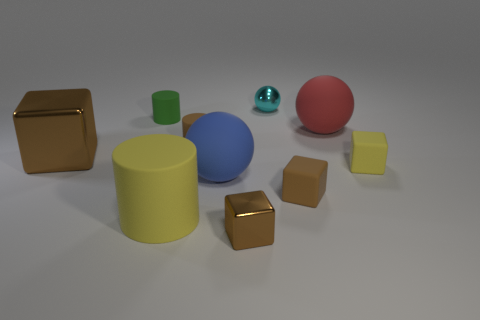Subtract all red cylinders. How many brown blocks are left? 3 Subtract 1 blocks. How many blocks are left? 3 Subtract all cylinders. How many objects are left? 7 Add 6 tiny brown cylinders. How many tiny brown cylinders are left? 7 Add 9 green matte cylinders. How many green matte cylinders exist? 10 Subtract 1 yellow cylinders. How many objects are left? 9 Subtract all large blue objects. Subtract all big yellow cylinders. How many objects are left? 8 